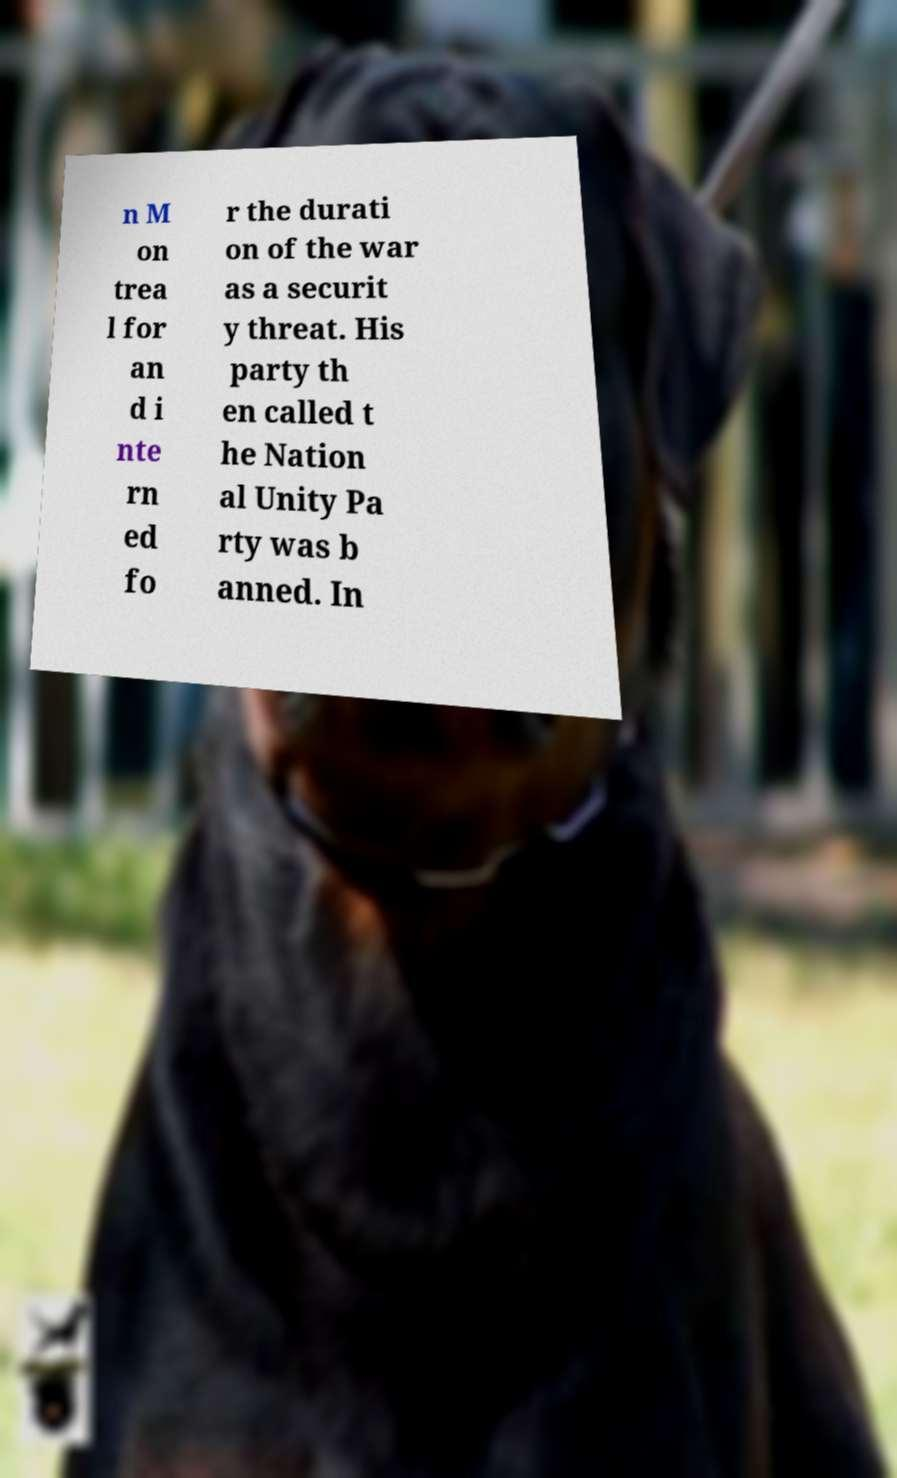Could you extract and type out the text from this image? n M on trea l for an d i nte rn ed fo r the durati on of the war as a securit y threat. His party th en called t he Nation al Unity Pa rty was b anned. In 